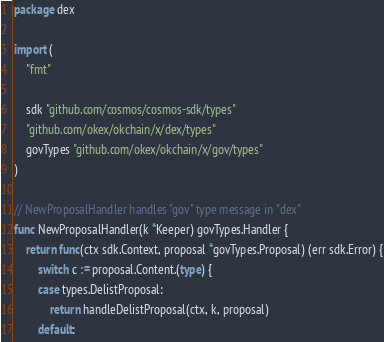Convert code to text. <code><loc_0><loc_0><loc_500><loc_500><_Go_>package dex

import (
	"fmt"

	sdk "github.com/cosmos/cosmos-sdk/types"
	"github.com/okex/okchain/x/dex/types"
	govTypes "github.com/okex/okchain/x/gov/types"
)

// NewProposalHandler handles "gov" type message in "dex"
func NewProposalHandler(k *Keeper) govTypes.Handler {
	return func(ctx sdk.Context, proposal *govTypes.Proposal) (err sdk.Error) {
		switch c := proposal.Content.(type) {
		case types.DelistProposal:
			return handleDelistProposal(ctx, k, proposal)
		default:</code> 